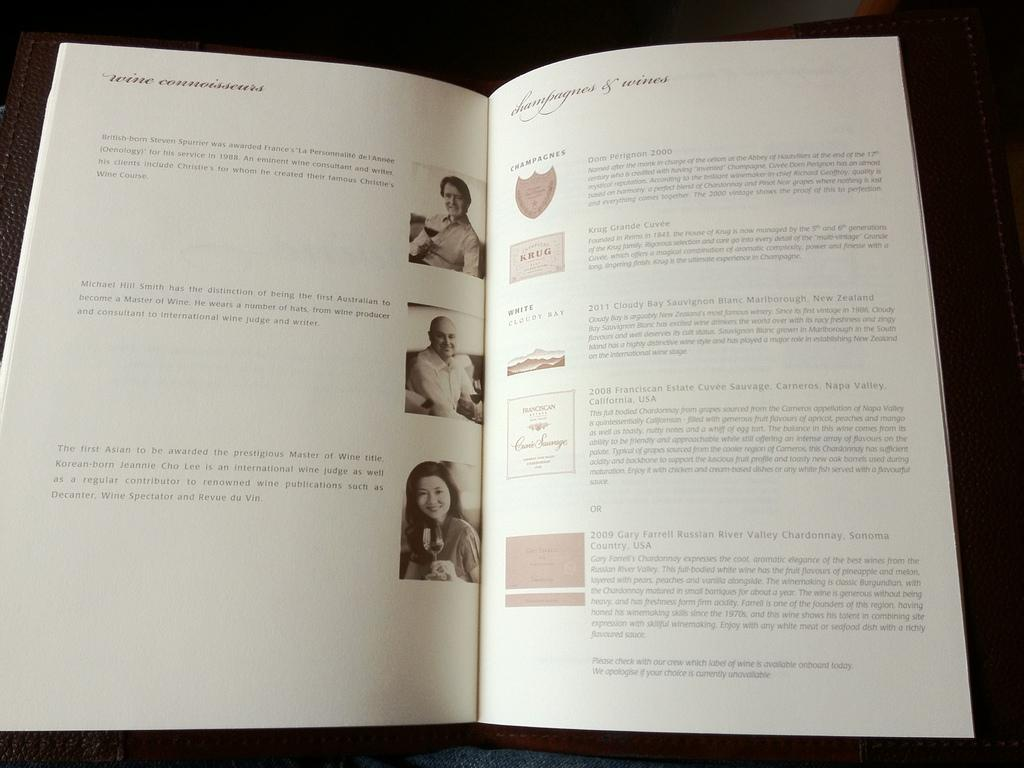<image>
Give a short and clear explanation of the subsequent image. Wine connoisseurs book open to the champagnes & wines page. 